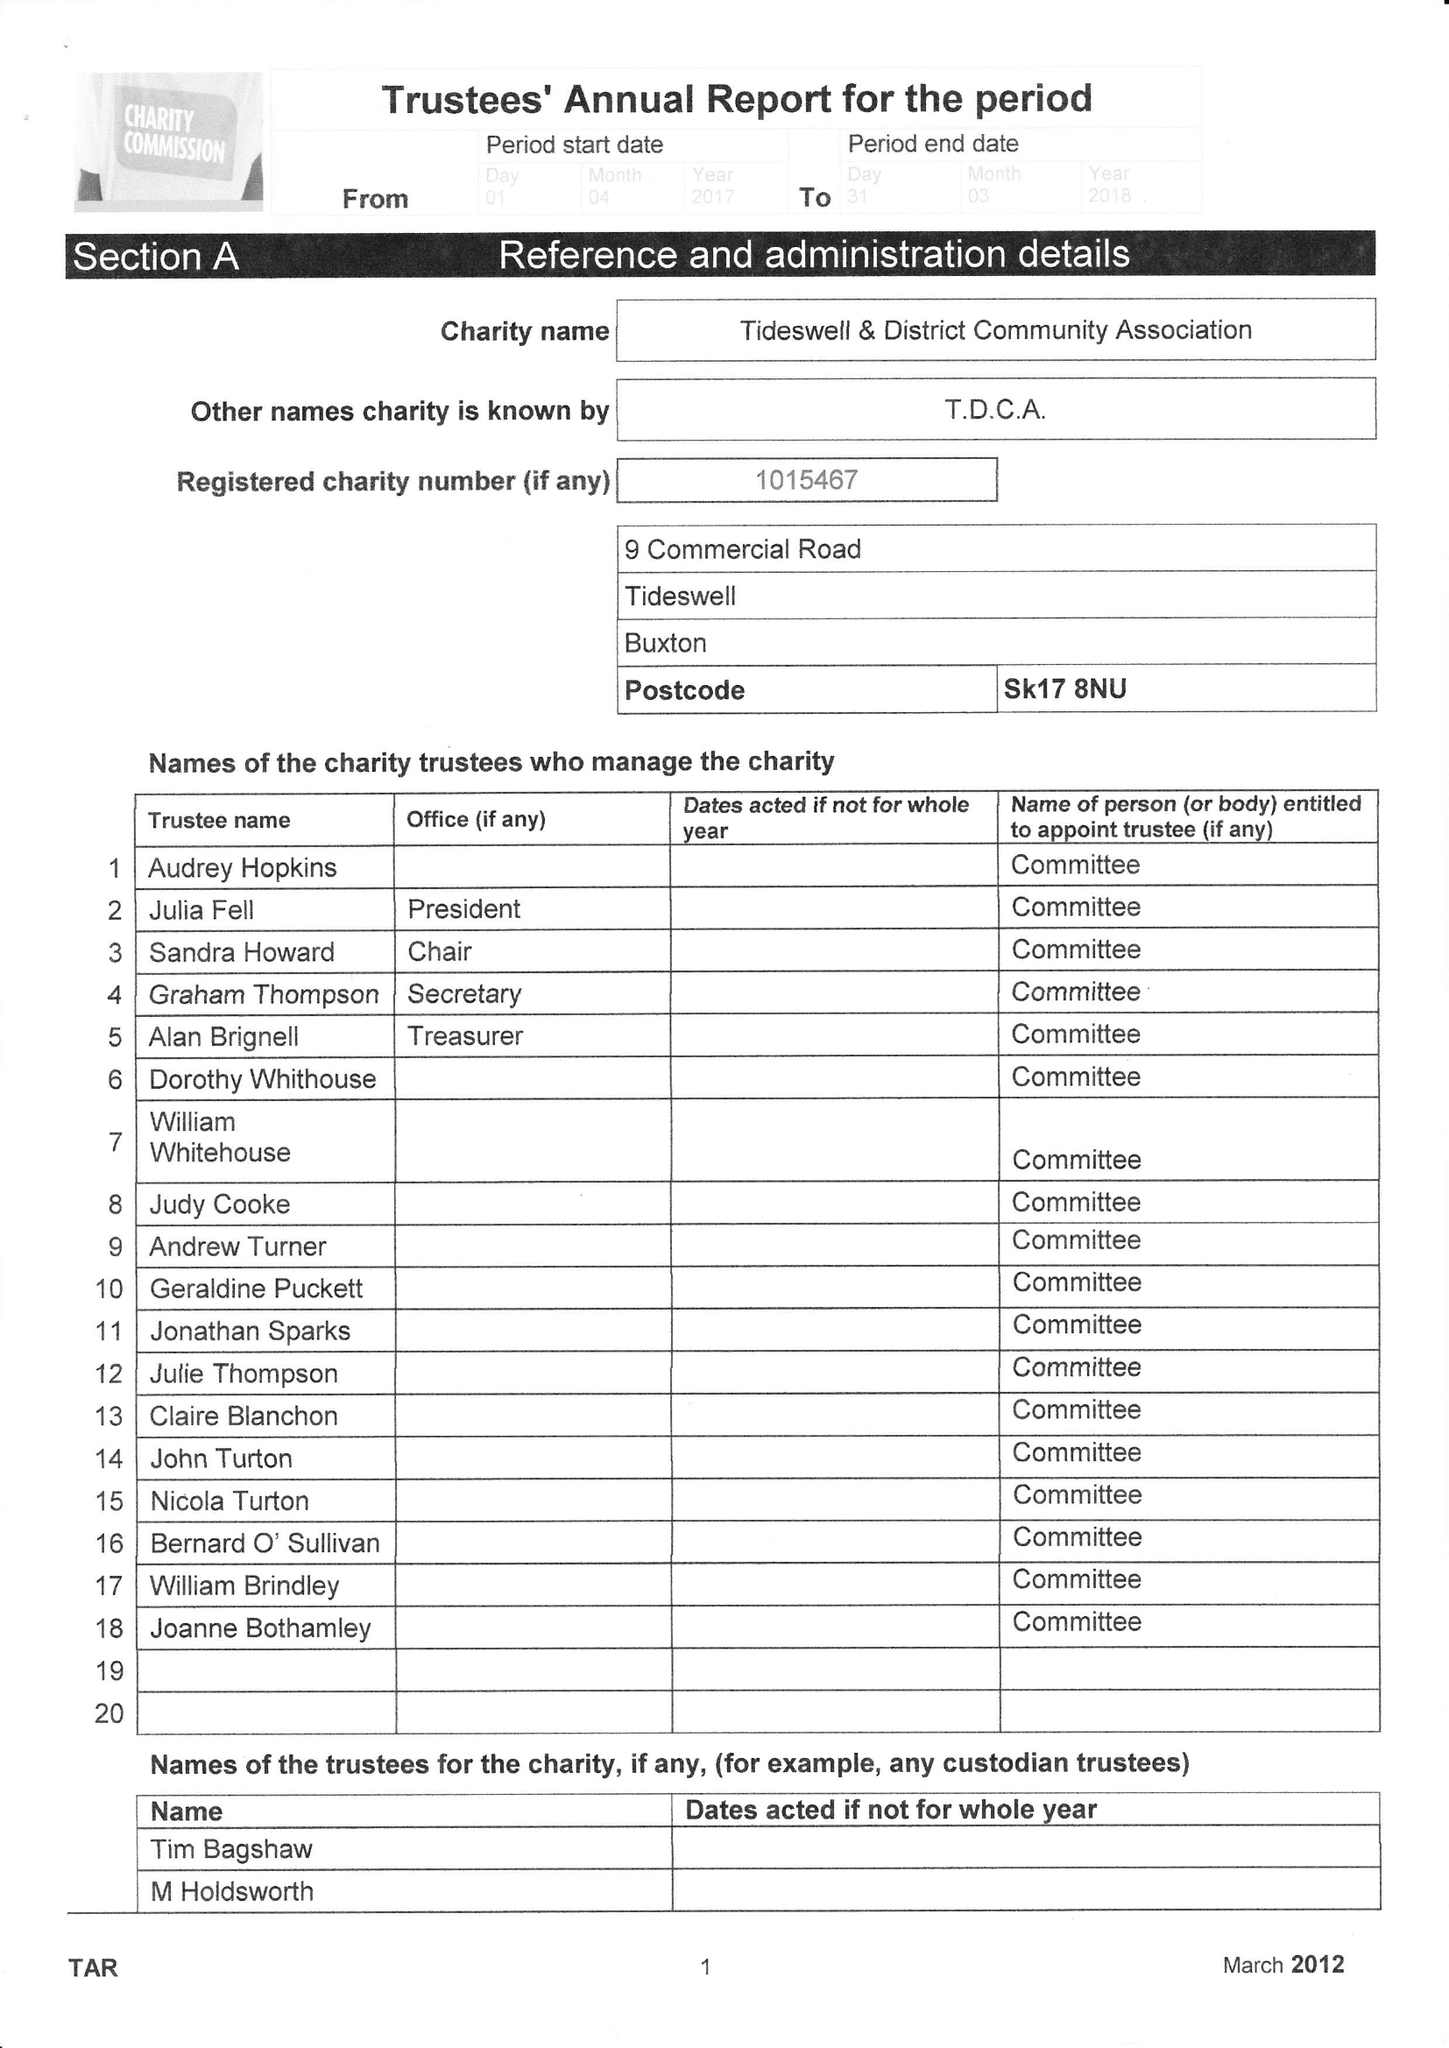What is the value for the address__postcode?
Answer the question using a single word or phrase. SK17 8NU 